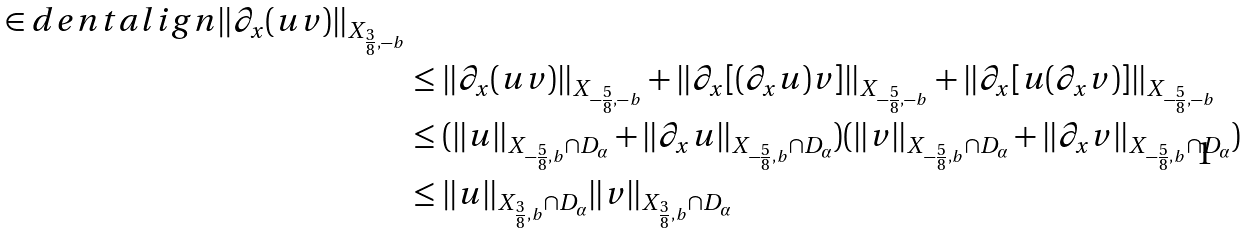Convert formula to latex. <formula><loc_0><loc_0><loc_500><loc_500>\in d e n t a l i g n \| \partial _ { x } ( u v ) \| _ { X _ { \frac { 3 } { 8 } , - b } } \\ & \leq \| \partial _ { x } ( u v ) \| _ { X _ { - \frac { 5 } { 8 } , - b } } + \| \partial _ { x } [ ( \partial _ { x } u ) v ] \| _ { X _ { - \frac { 5 } { 8 } , - b } } + \| \partial _ { x } [ u ( \partial _ { x } v ) ] \| _ { X _ { - \frac { 5 } { 8 } , - b } } \\ & \leq ( \| u \| _ { X _ { - \frac { 5 } { 8 } , b } \cap D _ { \alpha } } + \| \partial _ { x } u \| _ { X _ { - \frac { 5 } { 8 } , b } \cap D _ { \alpha } } ) ( \| v \| _ { X _ { - \frac { 5 } { 8 } , b } \cap D _ { \alpha } } + \| \partial _ { x } v \| _ { X _ { - \frac { 5 } { 8 } , b } \cap D _ { \alpha } } ) \\ & \leq \| u \| _ { X _ { \frac { 3 } { 8 } , b } \cap D _ { \alpha } } \| v \| _ { X _ { \frac { 3 } { 8 } , b } \cap D _ { \alpha } }</formula> 